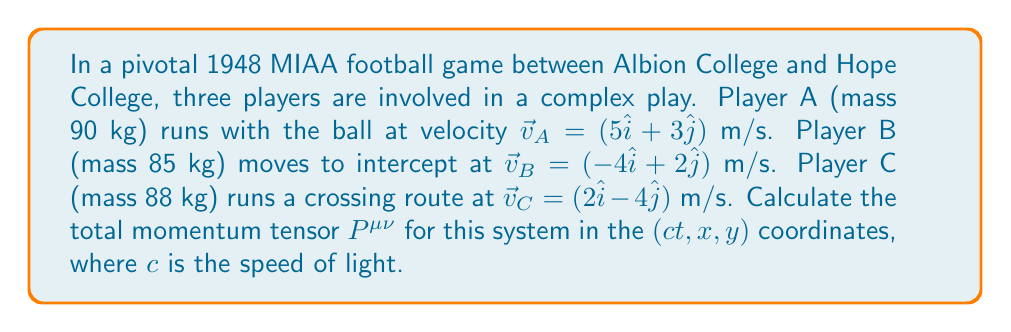Can you answer this question? Let's approach this step-by-step:

1) The momentum tensor $P^{\mu\nu}$ for a system of particles is given by:

   $$P^{\mu\nu} = \sum_i p_i^\mu p_i^\nu / E_i$$

   where $p_i^\mu$ is the four-momentum of the $i$-th particle, and $E_i$ is its energy.

2) For each player, we need to calculate the four-momentum $p^\mu = (E/c, p_x, p_y, 0)$. 
   The energy $E$ is given by $E = \gamma mc^2$, where $\gamma = 1/\sqrt{1-v^2/c^2}$.

3) Let's calculate $\gamma$ for each player:
   
   Player A: $v_A = \sqrt{5^2 + 3^2} = \sqrt{34}$ m/s
   Player B: $v_B = \sqrt{(-4)^2 + 2^2} = \sqrt{20}$ m/s
   Player C: $v_C = \sqrt{2^2 + (-4)^2} = \sqrt{20}$ m/s

   Since $v << c$ for all players, we can approximate $\gamma \approx 1$ for all.

4) Now, let's calculate the four-momentum for each player:

   Player A: $p_A^\mu = (90c, 450, 270, 0)$ kg⋅m/s
   Player B: $p_B^\mu = (85c, -340, 170, 0)$ kg⋅m/s
   Player C: $p_C^\mu = (88c, 176, -352, 0)$ kg⋅m/s

5) Now we can calculate each component of $P^{\mu\nu}$:

   $P^{00} = \sum_i (E_i/c)^2/E_i = (90+85+88)c = 263c$ kg
   
   $P^{01} = P^{10} = \sum_i (E_i/c)(p_x)_i/E_i = 450 - 340 + 176 = 286$ kg⋅m/s
   
   $P^{02} = P^{20} = \sum_i (E_i/c)(p_y)_i/E_i = 270 + 170 - 352 = 88$ kg⋅m/s
   
   $P^{11} = \sum_i (p_x)_i^2/E_i = (450^2 + 340^2 + 176^2)/(90c) = 3076/c$ kg⋅m/s
   
   $P^{12} = P^{21} = \sum_i (p_x)_i(p_y)_i/E_i = (450*270 - 340*170 + 176*(-352))/(90c) = 380/c$ kg⋅m/s
   
   $P^{22} = \sum_i (p_y)_i^2/E_i = (270^2 + 170^2 + 352^2)/(90c) = 1984/c$ kg⋅m/s

6) The final momentum tensor is:

   $$P^{\mu\nu} = \begin{pmatrix}
   263c & 286 & 88 \\
   286 & 3076/c & 380/c \\
   88 & 380/c & 1984/c
   \end{pmatrix}$$
Answer: $$P^{\mu\nu} = \begin{pmatrix}
263c & 286 & 88 \\
286 & 3076/c & 380/c \\
88 & 380/c & 1984/c
\end{pmatrix}$$ 